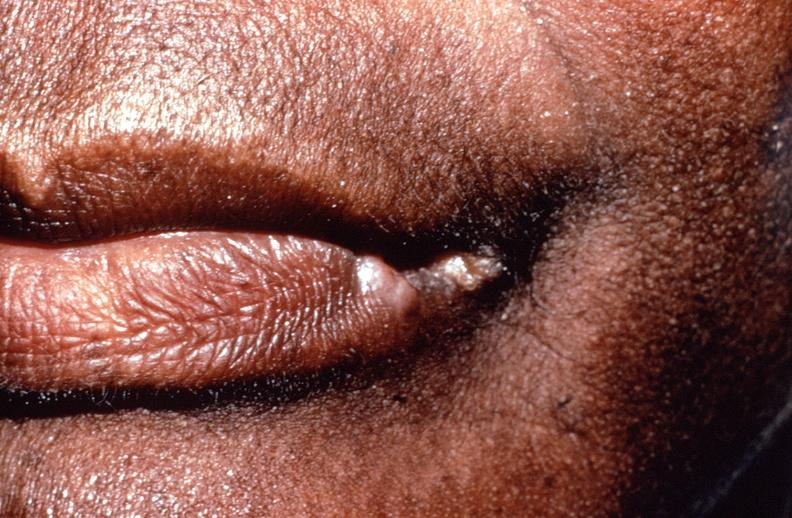s the excellent uterus healed?
Answer the question using a single word or phrase. No 